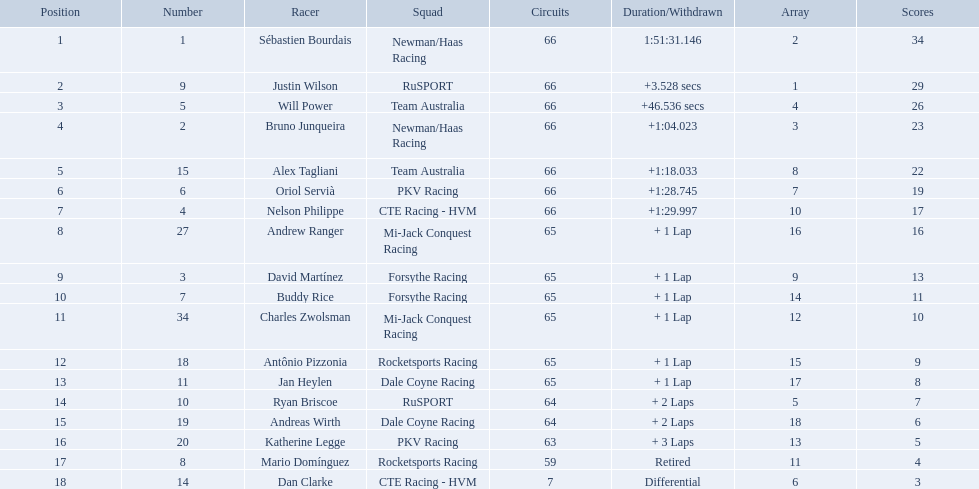How many points did first place receive? 34. How many did last place receive? 3. Who was the recipient of these last place points? Dan Clarke. What are the names of the drivers who were in position 14 through position 18? Ryan Briscoe, Andreas Wirth, Katherine Legge, Mario Domínguez, Dan Clarke. Of these , which ones didn't finish due to retired or differential? Mario Domínguez, Dan Clarke. Which one of the previous drivers retired? Mario Domínguez. Which of the drivers in question 2 had a differential? Dan Clarke. What drivers started in the top 10? Sébastien Bourdais, Justin Wilson, Will Power, Bruno Junqueira, Alex Tagliani, Oriol Servià, Nelson Philippe, Ryan Briscoe, Dan Clarke. Which of those drivers completed all 66 laps? Sébastien Bourdais, Justin Wilson, Will Power, Bruno Junqueira, Alex Tagliani, Oriol Servià, Nelson Philippe. Whom of these did not drive for team australia? Sébastien Bourdais, Justin Wilson, Bruno Junqueira, Oriol Servià, Nelson Philippe. Which of these drivers finished more then a minuet after the winner? Bruno Junqueira, Oriol Servià, Nelson Philippe. Which of these drivers had the highest car number? Oriol Servià. Parse the full table in json format. {'header': ['Position', 'Number', 'Racer', 'Squad', 'Circuits', 'Duration/Withdrawn', 'Array', 'Scores'], 'rows': [['1', '1', 'Sébastien Bourdais', 'Newman/Haas Racing', '66', '1:51:31.146', '2', '34'], ['2', '9', 'Justin Wilson', 'RuSPORT', '66', '+3.528 secs', '1', '29'], ['3', '5', 'Will Power', 'Team Australia', '66', '+46.536 secs', '4', '26'], ['4', '2', 'Bruno Junqueira', 'Newman/Haas Racing', '66', '+1:04.023', '3', '23'], ['5', '15', 'Alex Tagliani', 'Team Australia', '66', '+1:18.033', '8', '22'], ['6', '6', 'Oriol Servià', 'PKV Racing', '66', '+1:28.745', '7', '19'], ['7', '4', 'Nelson Philippe', 'CTE Racing - HVM', '66', '+1:29.997', '10', '17'], ['8', '27', 'Andrew Ranger', 'Mi-Jack Conquest Racing', '65', '+ 1 Lap', '16', '16'], ['9', '3', 'David Martínez', 'Forsythe Racing', '65', '+ 1 Lap', '9', '13'], ['10', '7', 'Buddy Rice', 'Forsythe Racing', '65', '+ 1 Lap', '14', '11'], ['11', '34', 'Charles Zwolsman', 'Mi-Jack Conquest Racing', '65', '+ 1 Lap', '12', '10'], ['12', '18', 'Antônio Pizzonia', 'Rocketsports Racing', '65', '+ 1 Lap', '15', '9'], ['13', '11', 'Jan Heylen', 'Dale Coyne Racing', '65', '+ 1 Lap', '17', '8'], ['14', '10', 'Ryan Briscoe', 'RuSPORT', '64', '+ 2 Laps', '5', '7'], ['15', '19', 'Andreas Wirth', 'Dale Coyne Racing', '64', '+ 2 Laps', '18', '6'], ['16', '20', 'Katherine Legge', 'PKV Racing', '63', '+ 3 Laps', '13', '5'], ['17', '8', 'Mario Domínguez', 'Rocketsports Racing', '59', 'Retired', '11', '4'], ['18', '14', 'Dan Clarke', 'CTE Racing - HVM', '7', 'Differential', '6', '3']]} Who are all of the 2006 gran premio telmex drivers? Sébastien Bourdais, Justin Wilson, Will Power, Bruno Junqueira, Alex Tagliani, Oriol Servià, Nelson Philippe, Andrew Ranger, David Martínez, Buddy Rice, Charles Zwolsman, Antônio Pizzonia, Jan Heylen, Ryan Briscoe, Andreas Wirth, Katherine Legge, Mario Domínguez, Dan Clarke. How many laps did they finish? 66, 66, 66, 66, 66, 66, 66, 65, 65, 65, 65, 65, 65, 64, 64, 63, 59, 7. What about just oriol servia and katherine legge? 66, 63. And which of those two drivers finished more laps? Oriol Servià. How many laps did oriol servia complete at the 2006 gran premio? 66. How many laps did katherine legge complete at the 2006 gran premio? 63. Between servia and legge, who completed more laps? Oriol Servià. Which drivers scored at least 10 points? Sébastien Bourdais, Justin Wilson, Will Power, Bruno Junqueira, Alex Tagliani, Oriol Servià, Nelson Philippe, Andrew Ranger, David Martínez, Buddy Rice, Charles Zwolsman. Of those drivers, which ones scored at least 20 points? Sébastien Bourdais, Justin Wilson, Will Power, Bruno Junqueira, Alex Tagliani. Of those 5, which driver scored the most points? Sébastien Bourdais. What are the drivers numbers? 1, 9, 5, 2, 15, 6, 4, 27, 3, 7, 34, 18, 11, 10, 19, 20, 8, 14. Are there any who's number matches his position? Sébastien Bourdais, Oriol Servià. Of those two who has the highest position? Sébastien Bourdais. Who are the drivers? Sébastien Bourdais, Justin Wilson, Will Power, Bruno Junqueira, Alex Tagliani, Oriol Servià, Nelson Philippe, Andrew Ranger, David Martínez, Buddy Rice, Charles Zwolsman, Antônio Pizzonia, Jan Heylen, Ryan Briscoe, Andreas Wirth, Katherine Legge, Mario Domínguez, Dan Clarke. What are their numbers? 1, 9, 5, 2, 15, 6, 4, 27, 3, 7, 34, 18, 11, 10, 19, 20, 8, 14. What are their positions? 1, 2, 3, 4, 5, 6, 7, 8, 9, 10, 11, 12, 13, 14, 15, 16, 17, 18. Which driver has the same number and position? Sébastien Bourdais. 